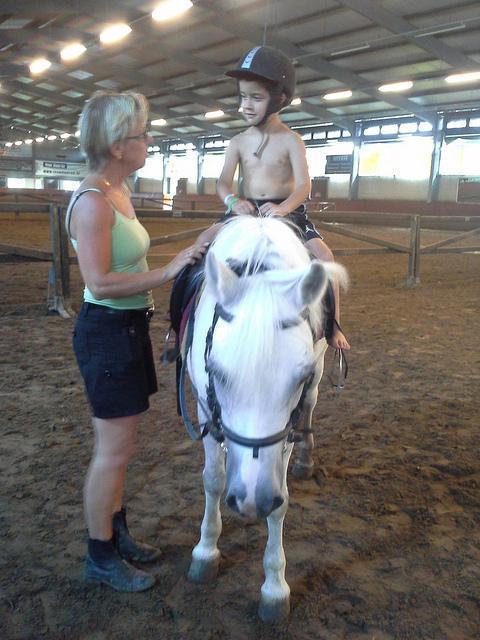How many people are in the photo?
Give a very brief answer. 2. 